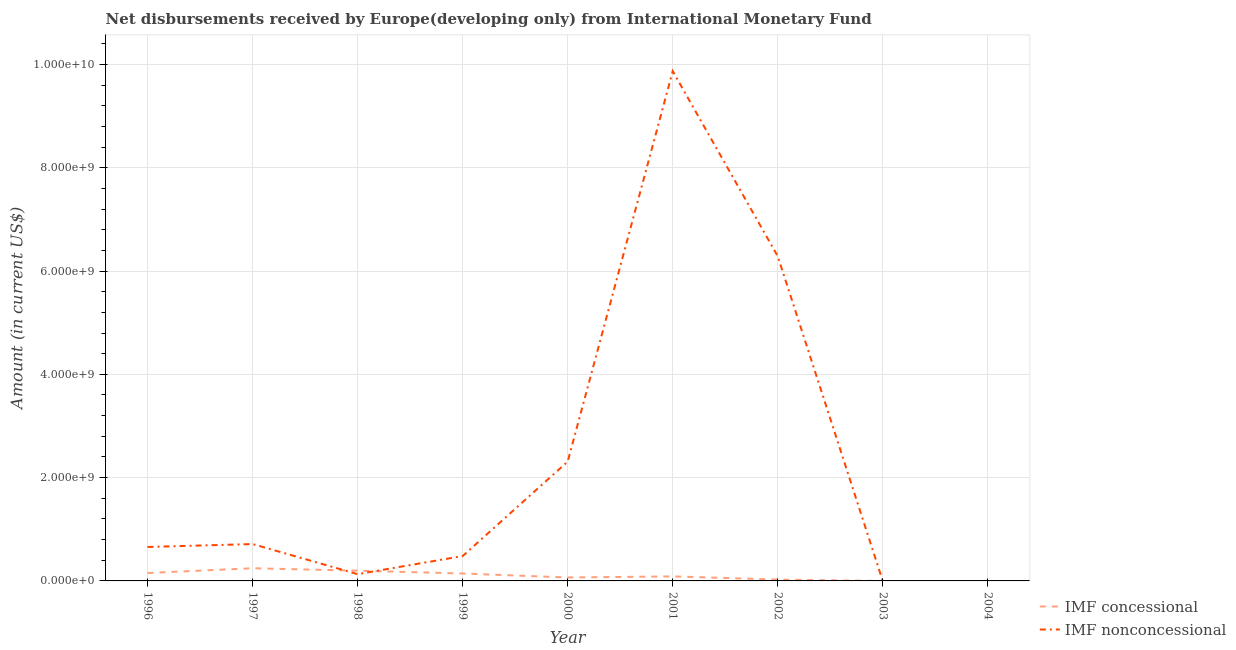How many different coloured lines are there?
Your response must be concise. 2. Does the line corresponding to net non concessional disbursements from imf intersect with the line corresponding to net concessional disbursements from imf?
Your response must be concise. Yes. Is the number of lines equal to the number of legend labels?
Your answer should be compact. No. Across all years, what is the maximum net non concessional disbursements from imf?
Give a very brief answer. 9.87e+09. Across all years, what is the minimum net concessional disbursements from imf?
Keep it short and to the point. 0. What is the total net concessional disbursements from imf in the graph?
Your response must be concise. 9.20e+08. What is the difference between the net non concessional disbursements from imf in 1998 and that in 2000?
Offer a terse response. -2.18e+09. What is the difference between the net concessional disbursements from imf in 2004 and the net non concessional disbursements from imf in 1997?
Provide a succinct answer. -7.14e+08. What is the average net concessional disbursements from imf per year?
Your response must be concise. 1.02e+08. In the year 2000, what is the difference between the net concessional disbursements from imf and net non concessional disbursements from imf?
Your answer should be compact. -2.24e+09. What is the ratio of the net non concessional disbursements from imf in 1996 to that in 2001?
Offer a terse response. 0.07. What is the difference between the highest and the second highest net non concessional disbursements from imf?
Offer a very short reply. 3.58e+09. What is the difference between the highest and the lowest net concessional disbursements from imf?
Keep it short and to the point. 2.45e+08. Is the sum of the net concessional disbursements from imf in 1998 and 2002 greater than the maximum net non concessional disbursements from imf across all years?
Offer a very short reply. No. Is the net concessional disbursements from imf strictly greater than the net non concessional disbursements from imf over the years?
Provide a short and direct response. No. How many lines are there?
Offer a very short reply. 2. Are the values on the major ticks of Y-axis written in scientific E-notation?
Give a very brief answer. Yes. What is the title of the graph?
Keep it short and to the point. Net disbursements received by Europe(developing only) from International Monetary Fund. What is the label or title of the Y-axis?
Provide a succinct answer. Amount (in current US$). What is the Amount (in current US$) in IMF concessional in 1996?
Give a very brief answer. 1.53e+08. What is the Amount (in current US$) in IMF nonconcessional in 1996?
Provide a short and direct response. 6.57e+08. What is the Amount (in current US$) of IMF concessional in 1997?
Give a very brief answer. 2.45e+08. What is the Amount (in current US$) of IMF nonconcessional in 1997?
Offer a terse response. 7.14e+08. What is the Amount (in current US$) in IMF concessional in 1998?
Offer a very short reply. 1.98e+08. What is the Amount (in current US$) in IMF nonconcessional in 1998?
Offer a terse response. 1.31e+08. What is the Amount (in current US$) of IMF concessional in 1999?
Keep it short and to the point. 1.44e+08. What is the Amount (in current US$) of IMF nonconcessional in 1999?
Your response must be concise. 4.82e+08. What is the Amount (in current US$) in IMF concessional in 2000?
Provide a short and direct response. 6.60e+07. What is the Amount (in current US$) of IMF nonconcessional in 2000?
Keep it short and to the point. 2.31e+09. What is the Amount (in current US$) of IMF concessional in 2001?
Your answer should be very brief. 8.76e+07. What is the Amount (in current US$) of IMF nonconcessional in 2001?
Your answer should be very brief. 9.87e+09. What is the Amount (in current US$) of IMF concessional in 2002?
Provide a short and direct response. 2.62e+07. What is the Amount (in current US$) of IMF nonconcessional in 2002?
Ensure brevity in your answer.  6.29e+09. What is the Amount (in current US$) in IMF concessional in 2003?
Make the answer very short. 0. What is the Amount (in current US$) of IMF nonconcessional in 2003?
Keep it short and to the point. 0. What is the Amount (in current US$) in IMF nonconcessional in 2004?
Provide a short and direct response. 0. Across all years, what is the maximum Amount (in current US$) in IMF concessional?
Provide a succinct answer. 2.45e+08. Across all years, what is the maximum Amount (in current US$) in IMF nonconcessional?
Ensure brevity in your answer.  9.87e+09. What is the total Amount (in current US$) of IMF concessional in the graph?
Make the answer very short. 9.20e+08. What is the total Amount (in current US$) in IMF nonconcessional in the graph?
Make the answer very short. 2.05e+1. What is the difference between the Amount (in current US$) of IMF concessional in 1996 and that in 1997?
Offer a very short reply. -9.25e+07. What is the difference between the Amount (in current US$) of IMF nonconcessional in 1996 and that in 1997?
Provide a succinct answer. -5.66e+07. What is the difference between the Amount (in current US$) in IMF concessional in 1996 and that in 1998?
Give a very brief answer. -4.54e+07. What is the difference between the Amount (in current US$) of IMF nonconcessional in 1996 and that in 1998?
Provide a short and direct response. 5.26e+08. What is the difference between the Amount (in current US$) in IMF concessional in 1996 and that in 1999?
Give a very brief answer. 9.22e+06. What is the difference between the Amount (in current US$) in IMF nonconcessional in 1996 and that in 1999?
Your answer should be compact. 1.76e+08. What is the difference between the Amount (in current US$) in IMF concessional in 1996 and that in 2000?
Your answer should be very brief. 8.70e+07. What is the difference between the Amount (in current US$) in IMF nonconcessional in 1996 and that in 2000?
Your answer should be compact. -1.65e+09. What is the difference between the Amount (in current US$) of IMF concessional in 1996 and that in 2001?
Make the answer very short. 6.54e+07. What is the difference between the Amount (in current US$) in IMF nonconcessional in 1996 and that in 2001?
Your response must be concise. -9.21e+09. What is the difference between the Amount (in current US$) of IMF concessional in 1996 and that in 2002?
Ensure brevity in your answer.  1.27e+08. What is the difference between the Amount (in current US$) in IMF nonconcessional in 1996 and that in 2002?
Your answer should be very brief. -5.63e+09. What is the difference between the Amount (in current US$) of IMF concessional in 1997 and that in 1998?
Provide a succinct answer. 4.71e+07. What is the difference between the Amount (in current US$) of IMF nonconcessional in 1997 and that in 1998?
Offer a very short reply. 5.83e+08. What is the difference between the Amount (in current US$) of IMF concessional in 1997 and that in 1999?
Provide a succinct answer. 1.02e+08. What is the difference between the Amount (in current US$) of IMF nonconcessional in 1997 and that in 1999?
Offer a terse response. 2.32e+08. What is the difference between the Amount (in current US$) of IMF concessional in 1997 and that in 2000?
Your answer should be very brief. 1.79e+08. What is the difference between the Amount (in current US$) of IMF nonconcessional in 1997 and that in 2000?
Your answer should be compact. -1.60e+09. What is the difference between the Amount (in current US$) in IMF concessional in 1997 and that in 2001?
Make the answer very short. 1.58e+08. What is the difference between the Amount (in current US$) in IMF nonconcessional in 1997 and that in 2001?
Your answer should be compact. -9.16e+09. What is the difference between the Amount (in current US$) in IMF concessional in 1997 and that in 2002?
Your response must be concise. 2.19e+08. What is the difference between the Amount (in current US$) of IMF nonconcessional in 1997 and that in 2002?
Your answer should be very brief. -5.57e+09. What is the difference between the Amount (in current US$) in IMF concessional in 1998 and that in 1999?
Offer a terse response. 5.46e+07. What is the difference between the Amount (in current US$) in IMF nonconcessional in 1998 and that in 1999?
Your response must be concise. -3.50e+08. What is the difference between the Amount (in current US$) in IMF concessional in 1998 and that in 2000?
Ensure brevity in your answer.  1.32e+08. What is the difference between the Amount (in current US$) in IMF nonconcessional in 1998 and that in 2000?
Offer a terse response. -2.18e+09. What is the difference between the Amount (in current US$) of IMF concessional in 1998 and that in 2001?
Keep it short and to the point. 1.11e+08. What is the difference between the Amount (in current US$) in IMF nonconcessional in 1998 and that in 2001?
Offer a terse response. -9.74e+09. What is the difference between the Amount (in current US$) in IMF concessional in 1998 and that in 2002?
Offer a very short reply. 1.72e+08. What is the difference between the Amount (in current US$) of IMF nonconcessional in 1998 and that in 2002?
Offer a very short reply. -6.15e+09. What is the difference between the Amount (in current US$) in IMF concessional in 1999 and that in 2000?
Offer a very short reply. 7.77e+07. What is the difference between the Amount (in current US$) in IMF nonconcessional in 1999 and that in 2000?
Offer a very short reply. -1.83e+09. What is the difference between the Amount (in current US$) of IMF concessional in 1999 and that in 2001?
Your answer should be compact. 5.62e+07. What is the difference between the Amount (in current US$) in IMF nonconcessional in 1999 and that in 2001?
Provide a short and direct response. -9.39e+09. What is the difference between the Amount (in current US$) of IMF concessional in 1999 and that in 2002?
Make the answer very short. 1.18e+08. What is the difference between the Amount (in current US$) of IMF nonconcessional in 1999 and that in 2002?
Provide a succinct answer. -5.80e+09. What is the difference between the Amount (in current US$) of IMF concessional in 2000 and that in 2001?
Your answer should be very brief. -2.15e+07. What is the difference between the Amount (in current US$) in IMF nonconcessional in 2000 and that in 2001?
Provide a succinct answer. -7.56e+09. What is the difference between the Amount (in current US$) of IMF concessional in 2000 and that in 2002?
Your answer should be compact. 3.98e+07. What is the difference between the Amount (in current US$) in IMF nonconcessional in 2000 and that in 2002?
Give a very brief answer. -3.97e+09. What is the difference between the Amount (in current US$) in IMF concessional in 2001 and that in 2002?
Keep it short and to the point. 6.14e+07. What is the difference between the Amount (in current US$) of IMF nonconcessional in 2001 and that in 2002?
Offer a terse response. 3.58e+09. What is the difference between the Amount (in current US$) of IMF concessional in 1996 and the Amount (in current US$) of IMF nonconcessional in 1997?
Keep it short and to the point. -5.61e+08. What is the difference between the Amount (in current US$) in IMF concessional in 1996 and the Amount (in current US$) in IMF nonconcessional in 1998?
Offer a terse response. 2.17e+07. What is the difference between the Amount (in current US$) of IMF concessional in 1996 and the Amount (in current US$) of IMF nonconcessional in 1999?
Offer a terse response. -3.29e+08. What is the difference between the Amount (in current US$) in IMF concessional in 1996 and the Amount (in current US$) in IMF nonconcessional in 2000?
Provide a succinct answer. -2.16e+09. What is the difference between the Amount (in current US$) of IMF concessional in 1996 and the Amount (in current US$) of IMF nonconcessional in 2001?
Make the answer very short. -9.72e+09. What is the difference between the Amount (in current US$) of IMF concessional in 1996 and the Amount (in current US$) of IMF nonconcessional in 2002?
Make the answer very short. -6.13e+09. What is the difference between the Amount (in current US$) in IMF concessional in 1997 and the Amount (in current US$) in IMF nonconcessional in 1998?
Make the answer very short. 1.14e+08. What is the difference between the Amount (in current US$) in IMF concessional in 1997 and the Amount (in current US$) in IMF nonconcessional in 1999?
Your answer should be compact. -2.36e+08. What is the difference between the Amount (in current US$) in IMF concessional in 1997 and the Amount (in current US$) in IMF nonconcessional in 2000?
Your answer should be very brief. -2.07e+09. What is the difference between the Amount (in current US$) of IMF concessional in 1997 and the Amount (in current US$) of IMF nonconcessional in 2001?
Keep it short and to the point. -9.62e+09. What is the difference between the Amount (in current US$) of IMF concessional in 1997 and the Amount (in current US$) of IMF nonconcessional in 2002?
Give a very brief answer. -6.04e+09. What is the difference between the Amount (in current US$) in IMF concessional in 1998 and the Amount (in current US$) in IMF nonconcessional in 1999?
Offer a terse response. -2.83e+08. What is the difference between the Amount (in current US$) of IMF concessional in 1998 and the Amount (in current US$) of IMF nonconcessional in 2000?
Your answer should be compact. -2.11e+09. What is the difference between the Amount (in current US$) in IMF concessional in 1998 and the Amount (in current US$) in IMF nonconcessional in 2001?
Your answer should be very brief. -9.67e+09. What is the difference between the Amount (in current US$) in IMF concessional in 1998 and the Amount (in current US$) in IMF nonconcessional in 2002?
Offer a very short reply. -6.09e+09. What is the difference between the Amount (in current US$) in IMF concessional in 1999 and the Amount (in current US$) in IMF nonconcessional in 2000?
Keep it short and to the point. -2.17e+09. What is the difference between the Amount (in current US$) of IMF concessional in 1999 and the Amount (in current US$) of IMF nonconcessional in 2001?
Your response must be concise. -9.73e+09. What is the difference between the Amount (in current US$) in IMF concessional in 1999 and the Amount (in current US$) in IMF nonconcessional in 2002?
Ensure brevity in your answer.  -6.14e+09. What is the difference between the Amount (in current US$) of IMF concessional in 2000 and the Amount (in current US$) of IMF nonconcessional in 2001?
Your answer should be very brief. -9.80e+09. What is the difference between the Amount (in current US$) of IMF concessional in 2000 and the Amount (in current US$) of IMF nonconcessional in 2002?
Your answer should be compact. -6.22e+09. What is the difference between the Amount (in current US$) of IMF concessional in 2001 and the Amount (in current US$) of IMF nonconcessional in 2002?
Your answer should be compact. -6.20e+09. What is the average Amount (in current US$) of IMF concessional per year?
Your response must be concise. 1.02e+08. What is the average Amount (in current US$) of IMF nonconcessional per year?
Give a very brief answer. 2.27e+09. In the year 1996, what is the difference between the Amount (in current US$) in IMF concessional and Amount (in current US$) in IMF nonconcessional?
Make the answer very short. -5.04e+08. In the year 1997, what is the difference between the Amount (in current US$) in IMF concessional and Amount (in current US$) in IMF nonconcessional?
Your answer should be compact. -4.68e+08. In the year 1998, what is the difference between the Amount (in current US$) in IMF concessional and Amount (in current US$) in IMF nonconcessional?
Offer a terse response. 6.71e+07. In the year 1999, what is the difference between the Amount (in current US$) of IMF concessional and Amount (in current US$) of IMF nonconcessional?
Keep it short and to the point. -3.38e+08. In the year 2000, what is the difference between the Amount (in current US$) in IMF concessional and Amount (in current US$) in IMF nonconcessional?
Your answer should be compact. -2.24e+09. In the year 2001, what is the difference between the Amount (in current US$) in IMF concessional and Amount (in current US$) in IMF nonconcessional?
Your response must be concise. -9.78e+09. In the year 2002, what is the difference between the Amount (in current US$) in IMF concessional and Amount (in current US$) in IMF nonconcessional?
Make the answer very short. -6.26e+09. What is the ratio of the Amount (in current US$) in IMF concessional in 1996 to that in 1997?
Give a very brief answer. 0.62. What is the ratio of the Amount (in current US$) of IMF nonconcessional in 1996 to that in 1997?
Give a very brief answer. 0.92. What is the ratio of the Amount (in current US$) in IMF concessional in 1996 to that in 1998?
Provide a succinct answer. 0.77. What is the ratio of the Amount (in current US$) of IMF nonconcessional in 1996 to that in 1998?
Your answer should be very brief. 5.01. What is the ratio of the Amount (in current US$) of IMF concessional in 1996 to that in 1999?
Provide a succinct answer. 1.06. What is the ratio of the Amount (in current US$) in IMF nonconcessional in 1996 to that in 1999?
Your answer should be compact. 1.37. What is the ratio of the Amount (in current US$) of IMF concessional in 1996 to that in 2000?
Keep it short and to the point. 2.32. What is the ratio of the Amount (in current US$) of IMF nonconcessional in 1996 to that in 2000?
Keep it short and to the point. 0.28. What is the ratio of the Amount (in current US$) of IMF concessional in 1996 to that in 2001?
Offer a very short reply. 1.75. What is the ratio of the Amount (in current US$) of IMF nonconcessional in 1996 to that in 2001?
Make the answer very short. 0.07. What is the ratio of the Amount (in current US$) in IMF concessional in 1996 to that in 2002?
Offer a very short reply. 5.84. What is the ratio of the Amount (in current US$) in IMF nonconcessional in 1996 to that in 2002?
Make the answer very short. 0.1. What is the ratio of the Amount (in current US$) in IMF concessional in 1997 to that in 1998?
Your answer should be compact. 1.24. What is the ratio of the Amount (in current US$) of IMF nonconcessional in 1997 to that in 1998?
Provide a short and direct response. 5.44. What is the ratio of the Amount (in current US$) of IMF concessional in 1997 to that in 1999?
Give a very brief answer. 1.71. What is the ratio of the Amount (in current US$) of IMF nonconcessional in 1997 to that in 1999?
Keep it short and to the point. 1.48. What is the ratio of the Amount (in current US$) of IMF concessional in 1997 to that in 2000?
Ensure brevity in your answer.  3.72. What is the ratio of the Amount (in current US$) of IMF nonconcessional in 1997 to that in 2000?
Provide a succinct answer. 0.31. What is the ratio of the Amount (in current US$) in IMF concessional in 1997 to that in 2001?
Your response must be concise. 2.8. What is the ratio of the Amount (in current US$) of IMF nonconcessional in 1997 to that in 2001?
Your answer should be very brief. 0.07. What is the ratio of the Amount (in current US$) of IMF concessional in 1997 to that in 2002?
Your answer should be compact. 9.36. What is the ratio of the Amount (in current US$) in IMF nonconcessional in 1997 to that in 2002?
Provide a short and direct response. 0.11. What is the ratio of the Amount (in current US$) of IMF concessional in 1998 to that in 1999?
Provide a succinct answer. 1.38. What is the ratio of the Amount (in current US$) of IMF nonconcessional in 1998 to that in 1999?
Your answer should be compact. 0.27. What is the ratio of the Amount (in current US$) in IMF concessional in 1998 to that in 2000?
Provide a succinct answer. 3. What is the ratio of the Amount (in current US$) of IMF nonconcessional in 1998 to that in 2000?
Offer a terse response. 0.06. What is the ratio of the Amount (in current US$) of IMF concessional in 1998 to that in 2001?
Ensure brevity in your answer.  2.27. What is the ratio of the Amount (in current US$) in IMF nonconcessional in 1998 to that in 2001?
Your answer should be very brief. 0.01. What is the ratio of the Amount (in current US$) in IMF concessional in 1998 to that in 2002?
Offer a very short reply. 7.57. What is the ratio of the Amount (in current US$) in IMF nonconcessional in 1998 to that in 2002?
Offer a terse response. 0.02. What is the ratio of the Amount (in current US$) of IMF concessional in 1999 to that in 2000?
Keep it short and to the point. 2.18. What is the ratio of the Amount (in current US$) of IMF nonconcessional in 1999 to that in 2000?
Provide a succinct answer. 0.21. What is the ratio of the Amount (in current US$) in IMF concessional in 1999 to that in 2001?
Make the answer very short. 1.64. What is the ratio of the Amount (in current US$) of IMF nonconcessional in 1999 to that in 2001?
Ensure brevity in your answer.  0.05. What is the ratio of the Amount (in current US$) of IMF concessional in 1999 to that in 2002?
Offer a terse response. 5.48. What is the ratio of the Amount (in current US$) in IMF nonconcessional in 1999 to that in 2002?
Provide a succinct answer. 0.08. What is the ratio of the Amount (in current US$) in IMF concessional in 2000 to that in 2001?
Keep it short and to the point. 0.75. What is the ratio of the Amount (in current US$) of IMF nonconcessional in 2000 to that in 2001?
Keep it short and to the point. 0.23. What is the ratio of the Amount (in current US$) of IMF concessional in 2000 to that in 2002?
Your answer should be compact. 2.52. What is the ratio of the Amount (in current US$) of IMF nonconcessional in 2000 to that in 2002?
Your answer should be compact. 0.37. What is the ratio of the Amount (in current US$) in IMF concessional in 2001 to that in 2002?
Offer a terse response. 3.34. What is the ratio of the Amount (in current US$) in IMF nonconcessional in 2001 to that in 2002?
Offer a terse response. 1.57. What is the difference between the highest and the second highest Amount (in current US$) of IMF concessional?
Keep it short and to the point. 4.71e+07. What is the difference between the highest and the second highest Amount (in current US$) of IMF nonconcessional?
Give a very brief answer. 3.58e+09. What is the difference between the highest and the lowest Amount (in current US$) of IMF concessional?
Your answer should be compact. 2.45e+08. What is the difference between the highest and the lowest Amount (in current US$) of IMF nonconcessional?
Your answer should be very brief. 9.87e+09. 